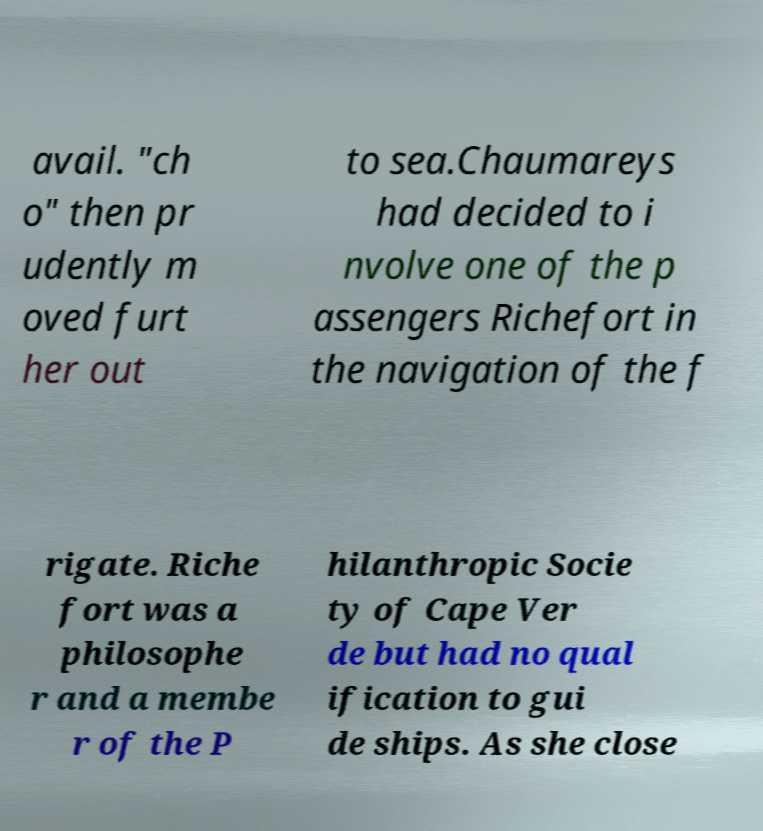Can you accurately transcribe the text from the provided image for me? avail. "ch o" then pr udently m oved furt her out to sea.Chaumareys had decided to i nvolve one of the p assengers Richefort in the navigation of the f rigate. Riche fort was a philosophe r and a membe r of the P hilanthropic Socie ty of Cape Ver de but had no qual ification to gui de ships. As she close 